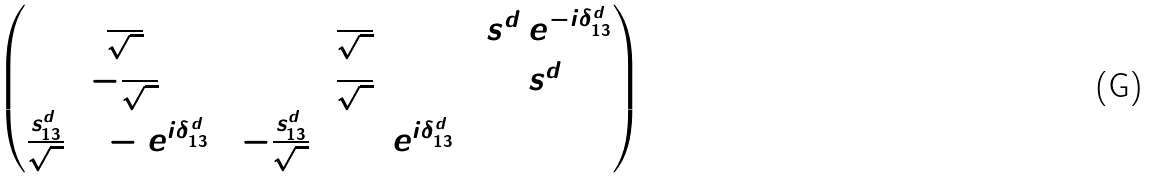<formula> <loc_0><loc_0><loc_500><loc_500>\begin{pmatrix} \frac { 1 } { \sqrt { 2 } } & \frac { 1 } { \sqrt { 2 } } & s _ { 1 3 } ^ { d } e ^ { - i \delta ^ { d } _ { 1 3 } } \\ - \frac { 1 } { \sqrt { 2 } } & \frac { 1 } { \sqrt { 2 } } & s _ { 1 3 } ^ { d } \\ \frac { s _ { 1 3 } ^ { d } } { \sqrt { 2 } } ( 1 - e ^ { i \delta ^ { d } _ { 1 3 } } ) & - \frac { s _ { 1 3 } ^ { d } } { \sqrt { 2 } } ( 1 + e ^ { i \delta ^ { d } _ { 1 3 } } ) & 1 \end{pmatrix}</formula> 